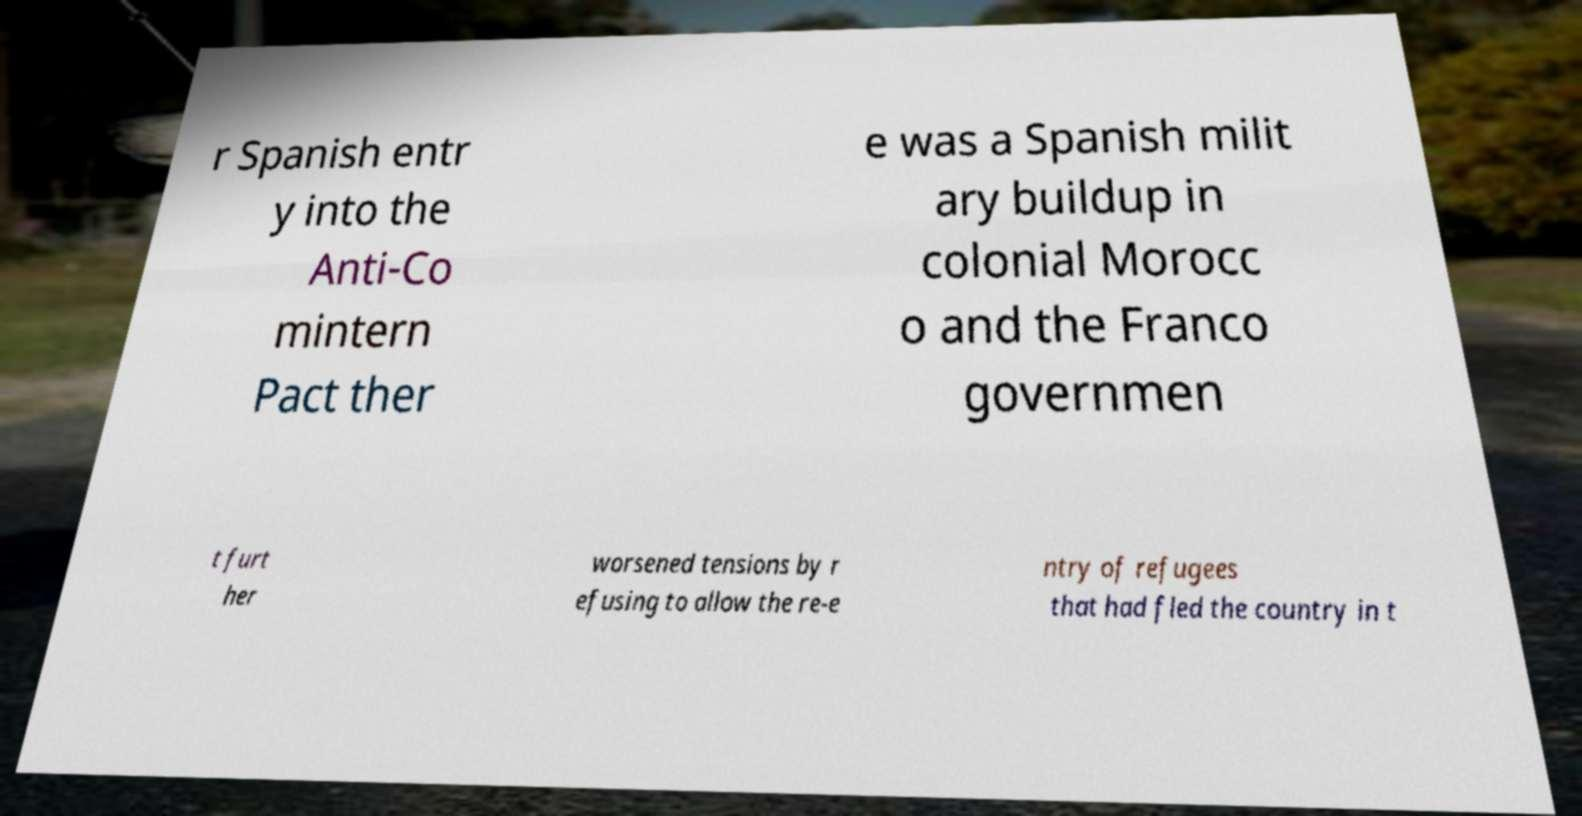What messages or text are displayed in this image? I need them in a readable, typed format. r Spanish entr y into the Anti-Co mintern Pact ther e was a Spanish milit ary buildup in colonial Morocc o and the Franco governmen t furt her worsened tensions by r efusing to allow the re-e ntry of refugees that had fled the country in t 